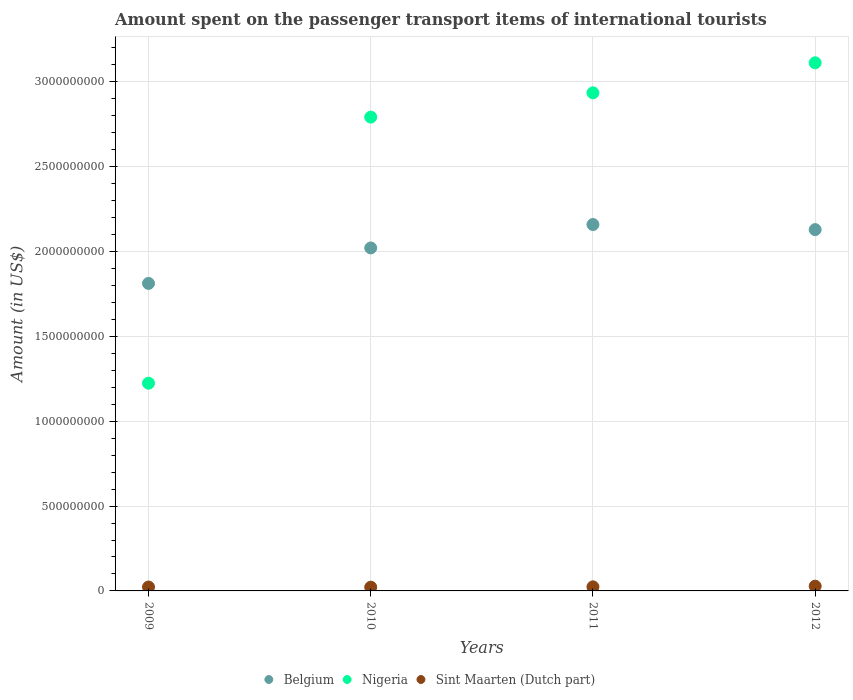How many different coloured dotlines are there?
Your answer should be compact. 3. What is the amount spent on the passenger transport items of international tourists in Sint Maarten (Dutch part) in 2012?
Your answer should be very brief. 2.80e+07. Across all years, what is the maximum amount spent on the passenger transport items of international tourists in Belgium?
Provide a short and direct response. 2.16e+09. Across all years, what is the minimum amount spent on the passenger transport items of international tourists in Nigeria?
Offer a terse response. 1.22e+09. In which year was the amount spent on the passenger transport items of international tourists in Belgium minimum?
Offer a very short reply. 2009. What is the total amount spent on the passenger transport items of international tourists in Sint Maarten (Dutch part) in the graph?
Give a very brief answer. 9.70e+07. What is the difference between the amount spent on the passenger transport items of international tourists in Nigeria in 2009 and that in 2012?
Your answer should be very brief. -1.89e+09. What is the difference between the amount spent on the passenger transport items of international tourists in Belgium in 2011 and the amount spent on the passenger transport items of international tourists in Nigeria in 2012?
Keep it short and to the point. -9.53e+08. What is the average amount spent on the passenger transport items of international tourists in Nigeria per year?
Your answer should be very brief. 2.52e+09. In the year 2009, what is the difference between the amount spent on the passenger transport items of international tourists in Belgium and amount spent on the passenger transport items of international tourists in Sint Maarten (Dutch part)?
Your answer should be compact. 1.79e+09. What is the ratio of the amount spent on the passenger transport items of international tourists in Nigeria in 2010 to that in 2011?
Give a very brief answer. 0.95. Is the amount spent on the passenger transport items of international tourists in Nigeria in 2011 less than that in 2012?
Give a very brief answer. Yes. Is the difference between the amount spent on the passenger transport items of international tourists in Belgium in 2009 and 2010 greater than the difference between the amount spent on the passenger transport items of international tourists in Sint Maarten (Dutch part) in 2009 and 2010?
Ensure brevity in your answer.  No. What is the difference between the highest and the second highest amount spent on the passenger transport items of international tourists in Nigeria?
Your response must be concise. 1.77e+08. What is the difference between the highest and the lowest amount spent on the passenger transport items of international tourists in Belgium?
Your answer should be very brief. 3.47e+08. In how many years, is the amount spent on the passenger transport items of international tourists in Sint Maarten (Dutch part) greater than the average amount spent on the passenger transport items of international tourists in Sint Maarten (Dutch part) taken over all years?
Keep it short and to the point. 1. Is it the case that in every year, the sum of the amount spent on the passenger transport items of international tourists in Sint Maarten (Dutch part) and amount spent on the passenger transport items of international tourists in Nigeria  is greater than the amount spent on the passenger transport items of international tourists in Belgium?
Offer a very short reply. No. Is the amount spent on the passenger transport items of international tourists in Nigeria strictly less than the amount spent on the passenger transport items of international tourists in Sint Maarten (Dutch part) over the years?
Ensure brevity in your answer.  No. How many dotlines are there?
Offer a terse response. 3. Are the values on the major ticks of Y-axis written in scientific E-notation?
Give a very brief answer. No. Does the graph contain grids?
Make the answer very short. Yes. Where does the legend appear in the graph?
Ensure brevity in your answer.  Bottom center. What is the title of the graph?
Your answer should be very brief. Amount spent on the passenger transport items of international tourists. Does "Montenegro" appear as one of the legend labels in the graph?
Give a very brief answer. No. What is the label or title of the X-axis?
Your answer should be compact. Years. What is the label or title of the Y-axis?
Offer a terse response. Amount (in US$). What is the Amount (in US$) in Belgium in 2009?
Provide a succinct answer. 1.81e+09. What is the Amount (in US$) in Nigeria in 2009?
Make the answer very short. 1.22e+09. What is the Amount (in US$) in Sint Maarten (Dutch part) in 2009?
Provide a succinct answer. 2.30e+07. What is the Amount (in US$) of Belgium in 2010?
Make the answer very short. 2.02e+09. What is the Amount (in US$) in Nigeria in 2010?
Offer a terse response. 2.79e+09. What is the Amount (in US$) of Sint Maarten (Dutch part) in 2010?
Make the answer very short. 2.20e+07. What is the Amount (in US$) of Belgium in 2011?
Ensure brevity in your answer.  2.16e+09. What is the Amount (in US$) in Nigeria in 2011?
Offer a very short reply. 2.94e+09. What is the Amount (in US$) in Sint Maarten (Dutch part) in 2011?
Give a very brief answer. 2.40e+07. What is the Amount (in US$) in Belgium in 2012?
Your answer should be very brief. 2.13e+09. What is the Amount (in US$) of Nigeria in 2012?
Keep it short and to the point. 3.11e+09. What is the Amount (in US$) of Sint Maarten (Dutch part) in 2012?
Offer a very short reply. 2.80e+07. Across all years, what is the maximum Amount (in US$) of Belgium?
Keep it short and to the point. 2.16e+09. Across all years, what is the maximum Amount (in US$) in Nigeria?
Your response must be concise. 3.11e+09. Across all years, what is the maximum Amount (in US$) in Sint Maarten (Dutch part)?
Offer a very short reply. 2.80e+07. Across all years, what is the minimum Amount (in US$) in Belgium?
Keep it short and to the point. 1.81e+09. Across all years, what is the minimum Amount (in US$) of Nigeria?
Ensure brevity in your answer.  1.22e+09. Across all years, what is the minimum Amount (in US$) in Sint Maarten (Dutch part)?
Provide a short and direct response. 2.20e+07. What is the total Amount (in US$) in Belgium in the graph?
Keep it short and to the point. 8.12e+09. What is the total Amount (in US$) of Nigeria in the graph?
Make the answer very short. 1.01e+1. What is the total Amount (in US$) of Sint Maarten (Dutch part) in the graph?
Ensure brevity in your answer.  9.70e+07. What is the difference between the Amount (in US$) in Belgium in 2009 and that in 2010?
Your answer should be very brief. -2.09e+08. What is the difference between the Amount (in US$) of Nigeria in 2009 and that in 2010?
Provide a succinct answer. -1.57e+09. What is the difference between the Amount (in US$) in Sint Maarten (Dutch part) in 2009 and that in 2010?
Your answer should be compact. 1.00e+06. What is the difference between the Amount (in US$) of Belgium in 2009 and that in 2011?
Provide a short and direct response. -3.47e+08. What is the difference between the Amount (in US$) of Nigeria in 2009 and that in 2011?
Ensure brevity in your answer.  -1.71e+09. What is the difference between the Amount (in US$) in Sint Maarten (Dutch part) in 2009 and that in 2011?
Offer a terse response. -1.00e+06. What is the difference between the Amount (in US$) of Belgium in 2009 and that in 2012?
Give a very brief answer. -3.17e+08. What is the difference between the Amount (in US$) of Nigeria in 2009 and that in 2012?
Keep it short and to the point. -1.89e+09. What is the difference between the Amount (in US$) in Sint Maarten (Dutch part) in 2009 and that in 2012?
Make the answer very short. -5.00e+06. What is the difference between the Amount (in US$) of Belgium in 2010 and that in 2011?
Your answer should be compact. -1.38e+08. What is the difference between the Amount (in US$) in Nigeria in 2010 and that in 2011?
Your response must be concise. -1.43e+08. What is the difference between the Amount (in US$) in Sint Maarten (Dutch part) in 2010 and that in 2011?
Offer a very short reply. -2.00e+06. What is the difference between the Amount (in US$) in Belgium in 2010 and that in 2012?
Provide a short and direct response. -1.08e+08. What is the difference between the Amount (in US$) in Nigeria in 2010 and that in 2012?
Make the answer very short. -3.20e+08. What is the difference between the Amount (in US$) of Sint Maarten (Dutch part) in 2010 and that in 2012?
Provide a short and direct response. -6.00e+06. What is the difference between the Amount (in US$) of Belgium in 2011 and that in 2012?
Give a very brief answer. 3.00e+07. What is the difference between the Amount (in US$) of Nigeria in 2011 and that in 2012?
Offer a terse response. -1.77e+08. What is the difference between the Amount (in US$) of Belgium in 2009 and the Amount (in US$) of Nigeria in 2010?
Provide a succinct answer. -9.80e+08. What is the difference between the Amount (in US$) of Belgium in 2009 and the Amount (in US$) of Sint Maarten (Dutch part) in 2010?
Keep it short and to the point. 1.79e+09. What is the difference between the Amount (in US$) of Nigeria in 2009 and the Amount (in US$) of Sint Maarten (Dutch part) in 2010?
Offer a very short reply. 1.20e+09. What is the difference between the Amount (in US$) of Belgium in 2009 and the Amount (in US$) of Nigeria in 2011?
Make the answer very short. -1.12e+09. What is the difference between the Amount (in US$) of Belgium in 2009 and the Amount (in US$) of Sint Maarten (Dutch part) in 2011?
Make the answer very short. 1.79e+09. What is the difference between the Amount (in US$) of Nigeria in 2009 and the Amount (in US$) of Sint Maarten (Dutch part) in 2011?
Keep it short and to the point. 1.20e+09. What is the difference between the Amount (in US$) of Belgium in 2009 and the Amount (in US$) of Nigeria in 2012?
Provide a succinct answer. -1.30e+09. What is the difference between the Amount (in US$) of Belgium in 2009 and the Amount (in US$) of Sint Maarten (Dutch part) in 2012?
Keep it short and to the point. 1.78e+09. What is the difference between the Amount (in US$) of Nigeria in 2009 and the Amount (in US$) of Sint Maarten (Dutch part) in 2012?
Give a very brief answer. 1.20e+09. What is the difference between the Amount (in US$) of Belgium in 2010 and the Amount (in US$) of Nigeria in 2011?
Offer a terse response. -9.14e+08. What is the difference between the Amount (in US$) in Belgium in 2010 and the Amount (in US$) in Sint Maarten (Dutch part) in 2011?
Offer a terse response. 2.00e+09. What is the difference between the Amount (in US$) in Nigeria in 2010 and the Amount (in US$) in Sint Maarten (Dutch part) in 2011?
Ensure brevity in your answer.  2.77e+09. What is the difference between the Amount (in US$) in Belgium in 2010 and the Amount (in US$) in Nigeria in 2012?
Your answer should be compact. -1.09e+09. What is the difference between the Amount (in US$) of Belgium in 2010 and the Amount (in US$) of Sint Maarten (Dutch part) in 2012?
Make the answer very short. 1.99e+09. What is the difference between the Amount (in US$) of Nigeria in 2010 and the Amount (in US$) of Sint Maarten (Dutch part) in 2012?
Offer a very short reply. 2.76e+09. What is the difference between the Amount (in US$) in Belgium in 2011 and the Amount (in US$) in Nigeria in 2012?
Give a very brief answer. -9.53e+08. What is the difference between the Amount (in US$) of Belgium in 2011 and the Amount (in US$) of Sint Maarten (Dutch part) in 2012?
Ensure brevity in your answer.  2.13e+09. What is the difference between the Amount (in US$) in Nigeria in 2011 and the Amount (in US$) in Sint Maarten (Dutch part) in 2012?
Your answer should be compact. 2.91e+09. What is the average Amount (in US$) of Belgium per year?
Your answer should be very brief. 2.03e+09. What is the average Amount (in US$) in Nigeria per year?
Your response must be concise. 2.52e+09. What is the average Amount (in US$) of Sint Maarten (Dutch part) per year?
Your response must be concise. 2.42e+07. In the year 2009, what is the difference between the Amount (in US$) in Belgium and Amount (in US$) in Nigeria?
Ensure brevity in your answer.  5.88e+08. In the year 2009, what is the difference between the Amount (in US$) in Belgium and Amount (in US$) in Sint Maarten (Dutch part)?
Your answer should be compact. 1.79e+09. In the year 2009, what is the difference between the Amount (in US$) in Nigeria and Amount (in US$) in Sint Maarten (Dutch part)?
Your answer should be very brief. 1.20e+09. In the year 2010, what is the difference between the Amount (in US$) in Belgium and Amount (in US$) in Nigeria?
Keep it short and to the point. -7.71e+08. In the year 2010, what is the difference between the Amount (in US$) in Belgium and Amount (in US$) in Sint Maarten (Dutch part)?
Ensure brevity in your answer.  2.00e+09. In the year 2010, what is the difference between the Amount (in US$) in Nigeria and Amount (in US$) in Sint Maarten (Dutch part)?
Ensure brevity in your answer.  2.77e+09. In the year 2011, what is the difference between the Amount (in US$) in Belgium and Amount (in US$) in Nigeria?
Your response must be concise. -7.76e+08. In the year 2011, what is the difference between the Amount (in US$) in Belgium and Amount (in US$) in Sint Maarten (Dutch part)?
Give a very brief answer. 2.14e+09. In the year 2011, what is the difference between the Amount (in US$) in Nigeria and Amount (in US$) in Sint Maarten (Dutch part)?
Your response must be concise. 2.91e+09. In the year 2012, what is the difference between the Amount (in US$) in Belgium and Amount (in US$) in Nigeria?
Ensure brevity in your answer.  -9.83e+08. In the year 2012, what is the difference between the Amount (in US$) of Belgium and Amount (in US$) of Sint Maarten (Dutch part)?
Provide a short and direct response. 2.10e+09. In the year 2012, what is the difference between the Amount (in US$) of Nigeria and Amount (in US$) of Sint Maarten (Dutch part)?
Make the answer very short. 3.08e+09. What is the ratio of the Amount (in US$) in Belgium in 2009 to that in 2010?
Keep it short and to the point. 0.9. What is the ratio of the Amount (in US$) in Nigeria in 2009 to that in 2010?
Your response must be concise. 0.44. What is the ratio of the Amount (in US$) in Sint Maarten (Dutch part) in 2009 to that in 2010?
Your answer should be compact. 1.05. What is the ratio of the Amount (in US$) in Belgium in 2009 to that in 2011?
Your response must be concise. 0.84. What is the ratio of the Amount (in US$) in Nigeria in 2009 to that in 2011?
Give a very brief answer. 0.42. What is the ratio of the Amount (in US$) of Belgium in 2009 to that in 2012?
Make the answer very short. 0.85. What is the ratio of the Amount (in US$) in Nigeria in 2009 to that in 2012?
Offer a terse response. 0.39. What is the ratio of the Amount (in US$) of Sint Maarten (Dutch part) in 2009 to that in 2012?
Your response must be concise. 0.82. What is the ratio of the Amount (in US$) in Belgium in 2010 to that in 2011?
Your answer should be very brief. 0.94. What is the ratio of the Amount (in US$) in Nigeria in 2010 to that in 2011?
Your answer should be compact. 0.95. What is the ratio of the Amount (in US$) of Sint Maarten (Dutch part) in 2010 to that in 2011?
Your answer should be very brief. 0.92. What is the ratio of the Amount (in US$) of Belgium in 2010 to that in 2012?
Ensure brevity in your answer.  0.95. What is the ratio of the Amount (in US$) in Nigeria in 2010 to that in 2012?
Make the answer very short. 0.9. What is the ratio of the Amount (in US$) of Sint Maarten (Dutch part) in 2010 to that in 2012?
Offer a very short reply. 0.79. What is the ratio of the Amount (in US$) of Belgium in 2011 to that in 2012?
Provide a succinct answer. 1.01. What is the ratio of the Amount (in US$) in Nigeria in 2011 to that in 2012?
Your answer should be very brief. 0.94. What is the difference between the highest and the second highest Amount (in US$) of Belgium?
Ensure brevity in your answer.  3.00e+07. What is the difference between the highest and the second highest Amount (in US$) in Nigeria?
Your answer should be very brief. 1.77e+08. What is the difference between the highest and the lowest Amount (in US$) in Belgium?
Offer a very short reply. 3.47e+08. What is the difference between the highest and the lowest Amount (in US$) in Nigeria?
Your answer should be very brief. 1.89e+09. What is the difference between the highest and the lowest Amount (in US$) in Sint Maarten (Dutch part)?
Keep it short and to the point. 6.00e+06. 